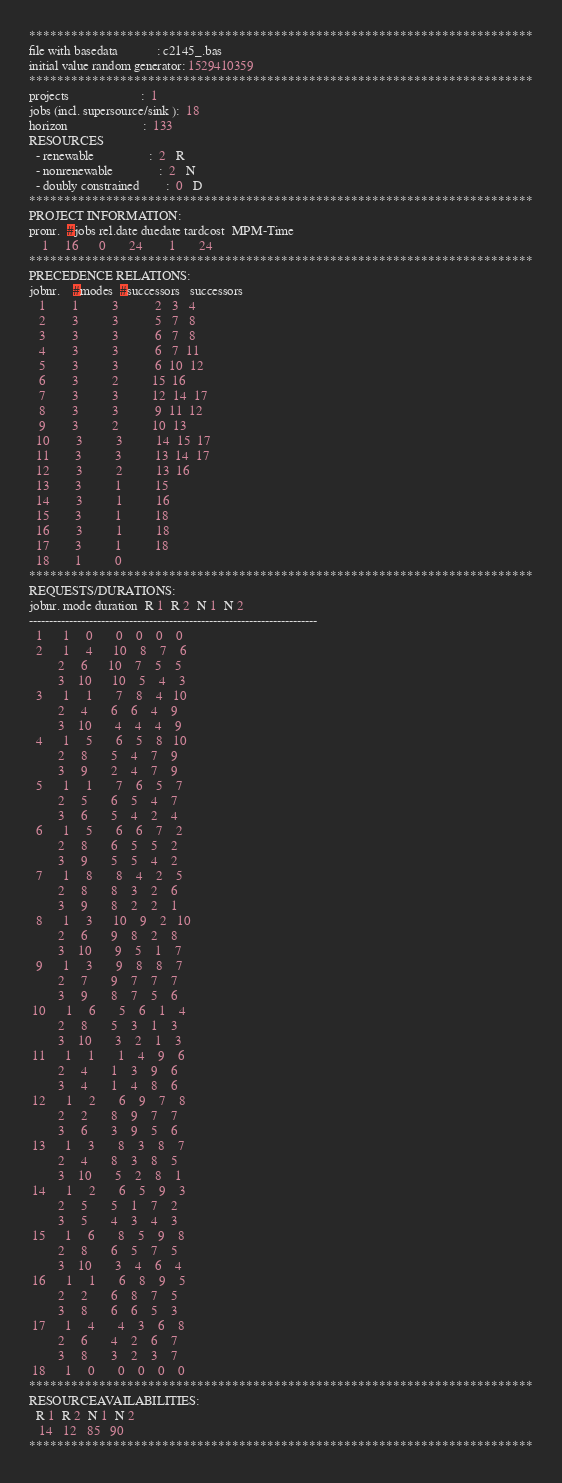<code> <loc_0><loc_0><loc_500><loc_500><_ObjectiveC_>************************************************************************
file with basedata            : c2145_.bas
initial value random generator: 1529410359
************************************************************************
projects                      :  1
jobs (incl. supersource/sink ):  18
horizon                       :  133
RESOURCES
  - renewable                 :  2   R
  - nonrenewable              :  2   N
  - doubly constrained        :  0   D
************************************************************************
PROJECT INFORMATION:
pronr.  #jobs rel.date duedate tardcost  MPM-Time
    1     16      0       24        1       24
************************************************************************
PRECEDENCE RELATIONS:
jobnr.    #modes  #successors   successors
   1        1          3           2   3   4
   2        3          3           5   7   8
   3        3          3           6   7   8
   4        3          3           6   7  11
   5        3          3           6  10  12
   6        3          2          15  16
   7        3          3          12  14  17
   8        3          3           9  11  12
   9        3          2          10  13
  10        3          3          14  15  17
  11        3          3          13  14  17
  12        3          2          13  16
  13        3          1          15
  14        3          1          16
  15        3          1          18
  16        3          1          18
  17        3          1          18
  18        1          0        
************************************************************************
REQUESTS/DURATIONS:
jobnr. mode duration  R 1  R 2  N 1  N 2
------------------------------------------------------------------------
  1      1     0       0    0    0    0
  2      1     4      10    8    7    6
         2     6      10    7    5    5
         3    10      10    5    4    3
  3      1     1       7    8    4   10
         2     4       6    6    4    9
         3    10       4    4    4    9
  4      1     5       6    5    8   10
         2     8       5    4    7    9
         3     9       2    4    7    9
  5      1     1       7    6    5    7
         2     5       6    5    4    7
         3     6       5    4    2    4
  6      1     5       6    6    7    2
         2     8       6    5    5    2
         3     9       5    5    4    2
  7      1     8       8    4    2    5
         2     8       8    3    2    6
         3     9       8    2    2    1
  8      1     3      10    9    2   10
         2     6       9    8    2    8
         3    10       9    5    1    7
  9      1     3       9    8    8    7
         2     7       9    7    7    7
         3     9       8    7    5    6
 10      1     6       5    6    1    4
         2     8       5    3    1    3
         3    10       3    2    1    3
 11      1     1       1    4    9    6
         2     4       1    3    9    6
         3     4       1    4    8    6
 12      1     2       6    9    7    8
         2     2       8    9    7    7
         3     6       3    9    5    6
 13      1     3       8    3    8    7
         2     4       8    3    8    5
         3    10       5    2    8    1
 14      1     2       6    5    9    3
         2     5       5    1    7    2
         3     5       4    3    4    3
 15      1     6       8    5    9    8
         2     8       6    5    7    5
         3    10       3    4    6    4
 16      1     1       6    8    9    5
         2     2       6    8    7    5
         3     8       6    6    5    3
 17      1     4       4    3    6    8
         2     6       4    2    6    7
         3     8       3    2    3    7
 18      1     0       0    0    0    0
************************************************************************
RESOURCEAVAILABILITIES:
  R 1  R 2  N 1  N 2
   14   12   85   90
************************************************************************
</code> 